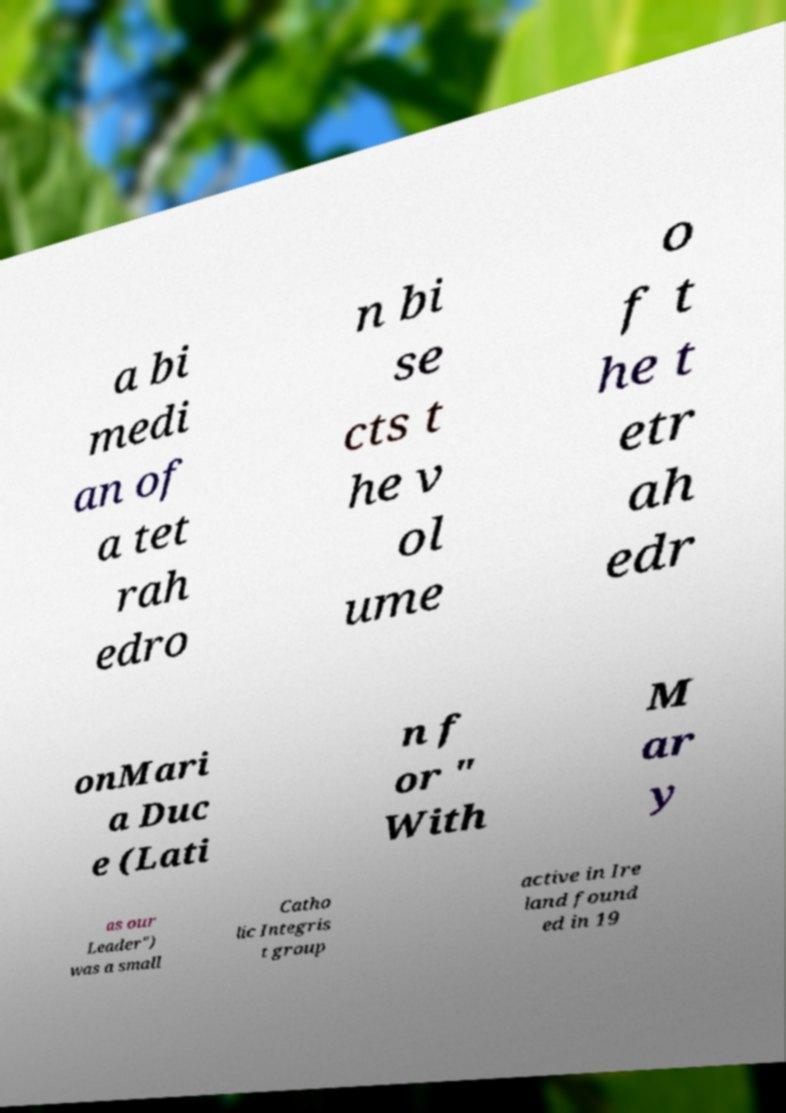For documentation purposes, I need the text within this image transcribed. Could you provide that? a bi medi an of a tet rah edro n bi se cts t he v ol ume o f t he t etr ah edr onMari a Duc e (Lati n f or " With M ar y as our Leader") was a small Catho lic Integris t group active in Ire land found ed in 19 